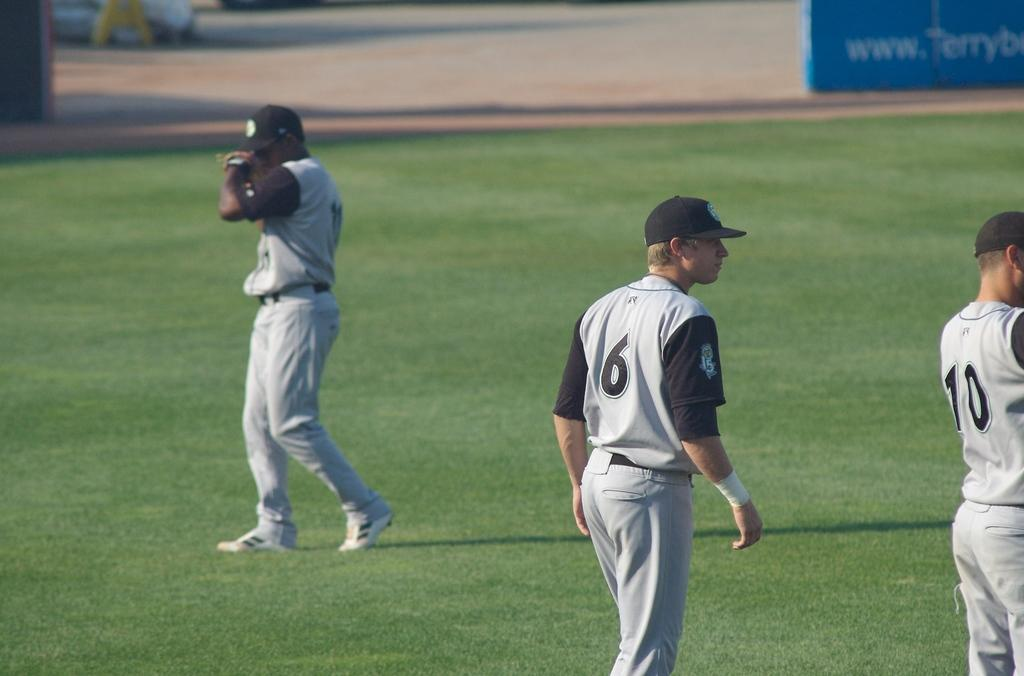<image>
Write a terse but informative summary of the picture. Three baseball players in the outfield, #6, and # 10. 